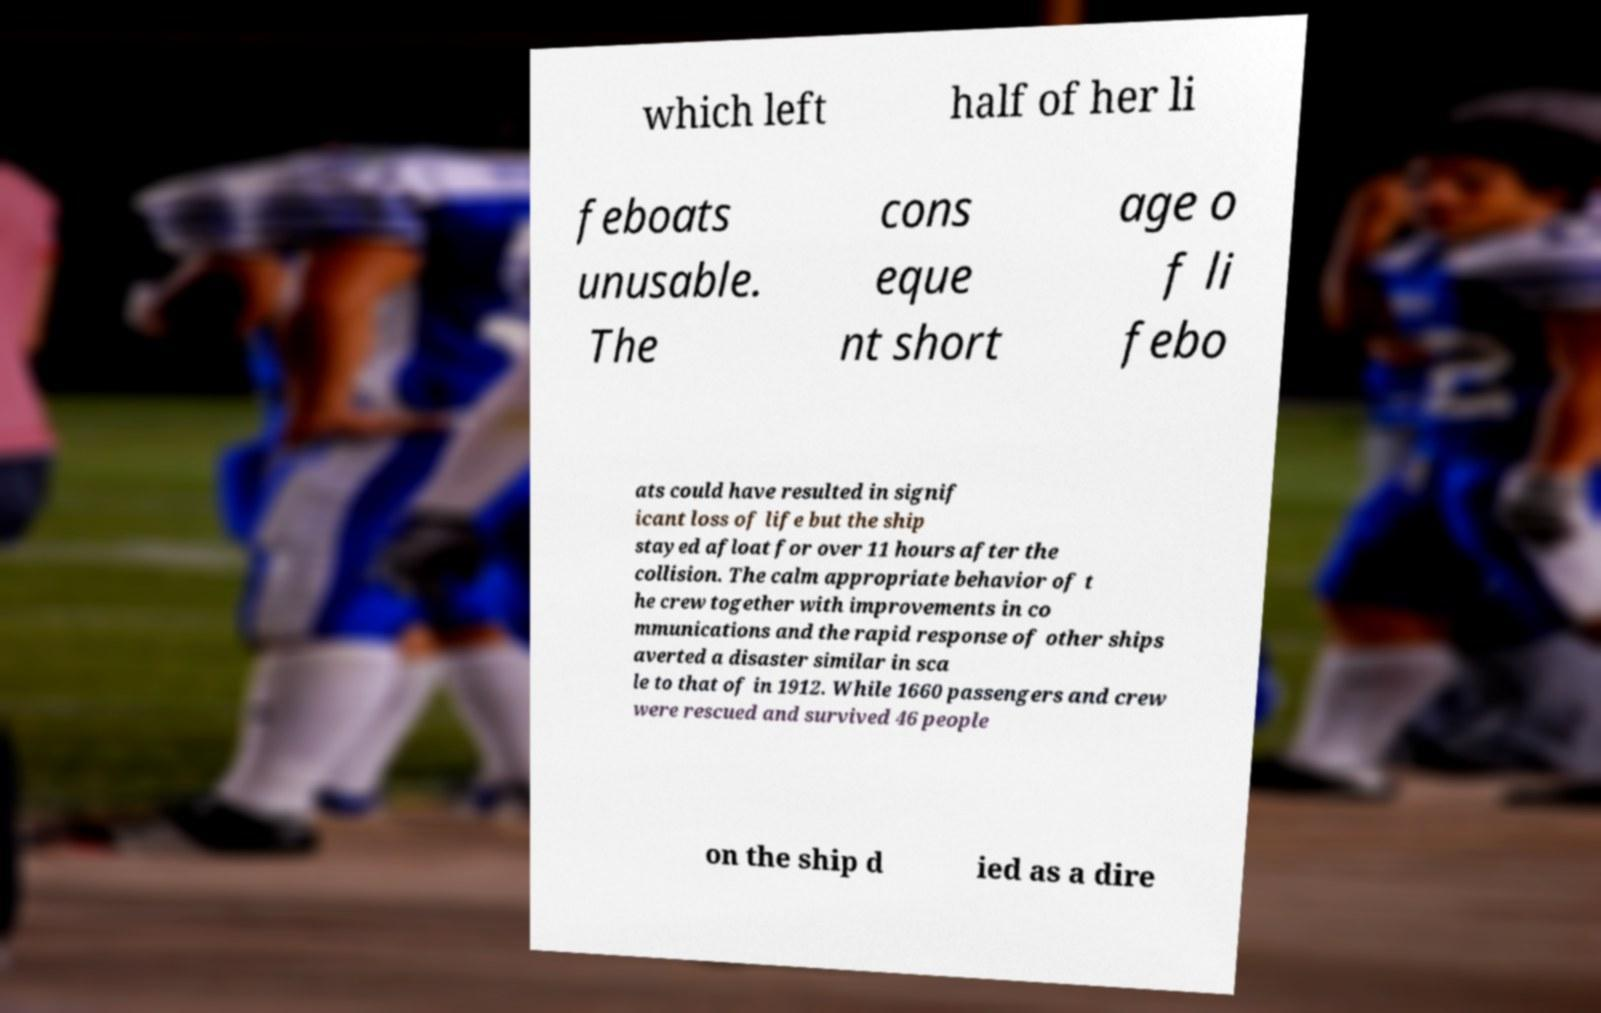For documentation purposes, I need the text within this image transcribed. Could you provide that? which left half of her li feboats unusable. The cons eque nt short age o f li febo ats could have resulted in signif icant loss of life but the ship stayed afloat for over 11 hours after the collision. The calm appropriate behavior of t he crew together with improvements in co mmunications and the rapid response of other ships averted a disaster similar in sca le to that of in 1912. While 1660 passengers and crew were rescued and survived 46 people on the ship d ied as a dire 